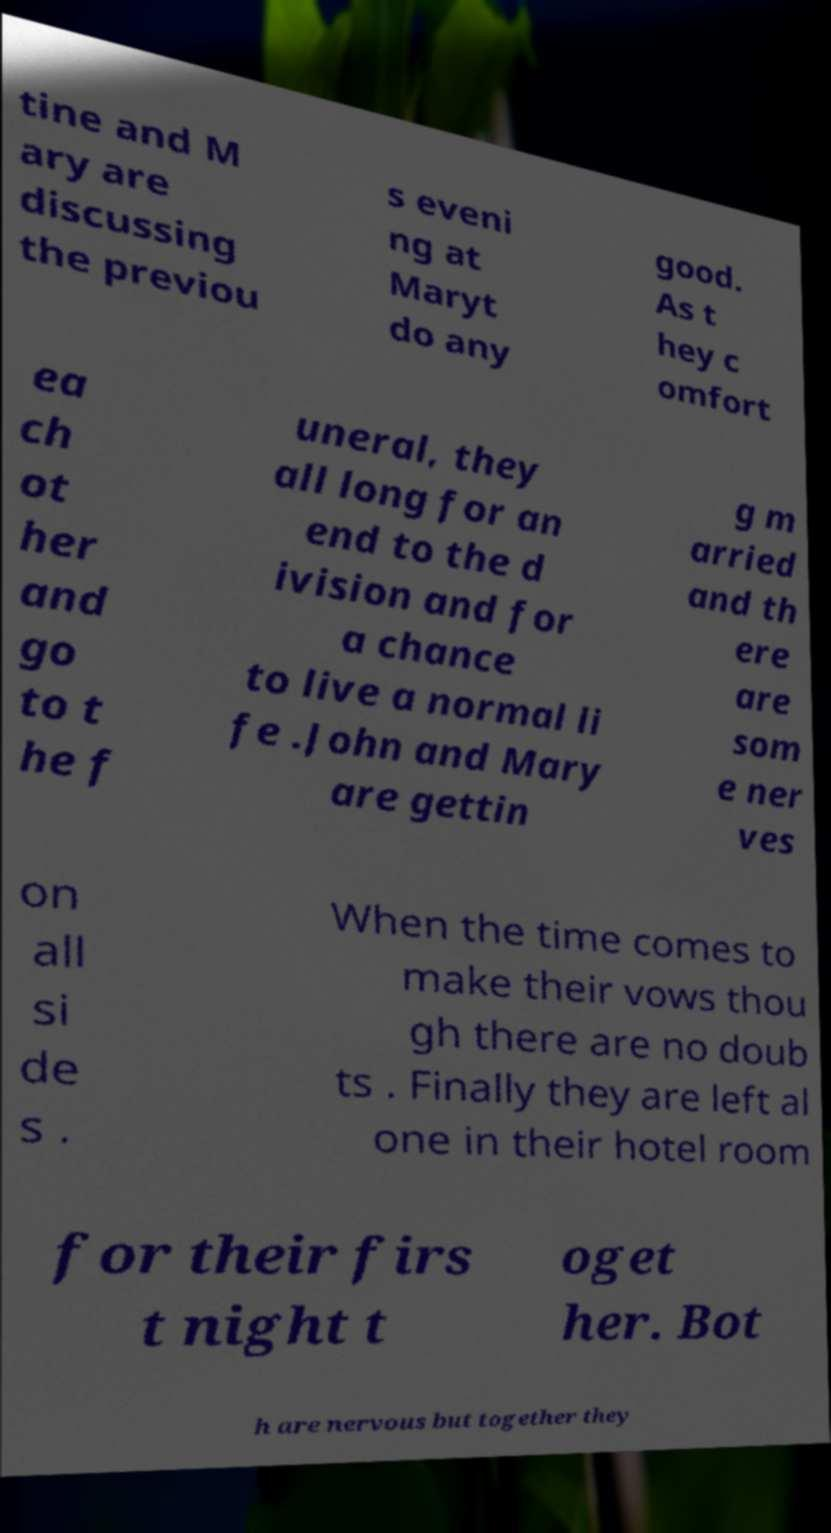What messages or text are displayed in this image? I need them in a readable, typed format. tine and M ary are discussing the previou s eveni ng at Maryt do any good. As t hey c omfort ea ch ot her and go to t he f uneral, they all long for an end to the d ivision and for a chance to live a normal li fe .John and Mary are gettin g m arried and th ere are som e ner ves on all si de s . When the time comes to make their vows thou gh there are no doub ts . Finally they are left al one in their hotel room for their firs t night t oget her. Bot h are nervous but together they 